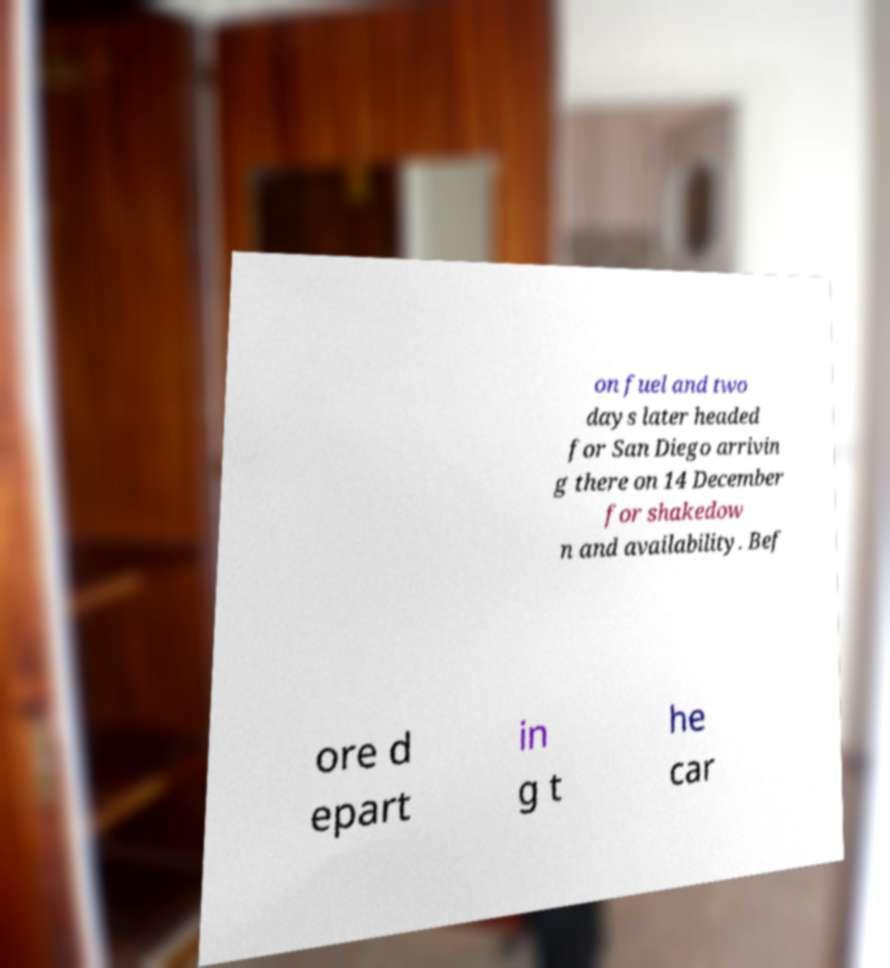There's text embedded in this image that I need extracted. Can you transcribe it verbatim? on fuel and two days later headed for San Diego arrivin g there on 14 December for shakedow n and availability. Bef ore d epart in g t he car 